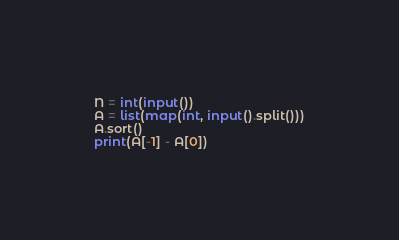Convert code to text. <code><loc_0><loc_0><loc_500><loc_500><_Python_>N = int(input())
A = list(map(int, input().split()))
A.sort()
print(A[-1] - A[0])</code> 